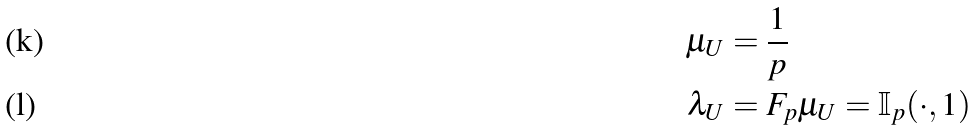Convert formula to latex. <formula><loc_0><loc_0><loc_500><loc_500>\mu _ { U } & = \frac { 1 } { p } \\ \lambda _ { U } & = F _ { p } \mu _ { U } = \mathbb { I } _ { p } ( \cdot , 1 )</formula> 